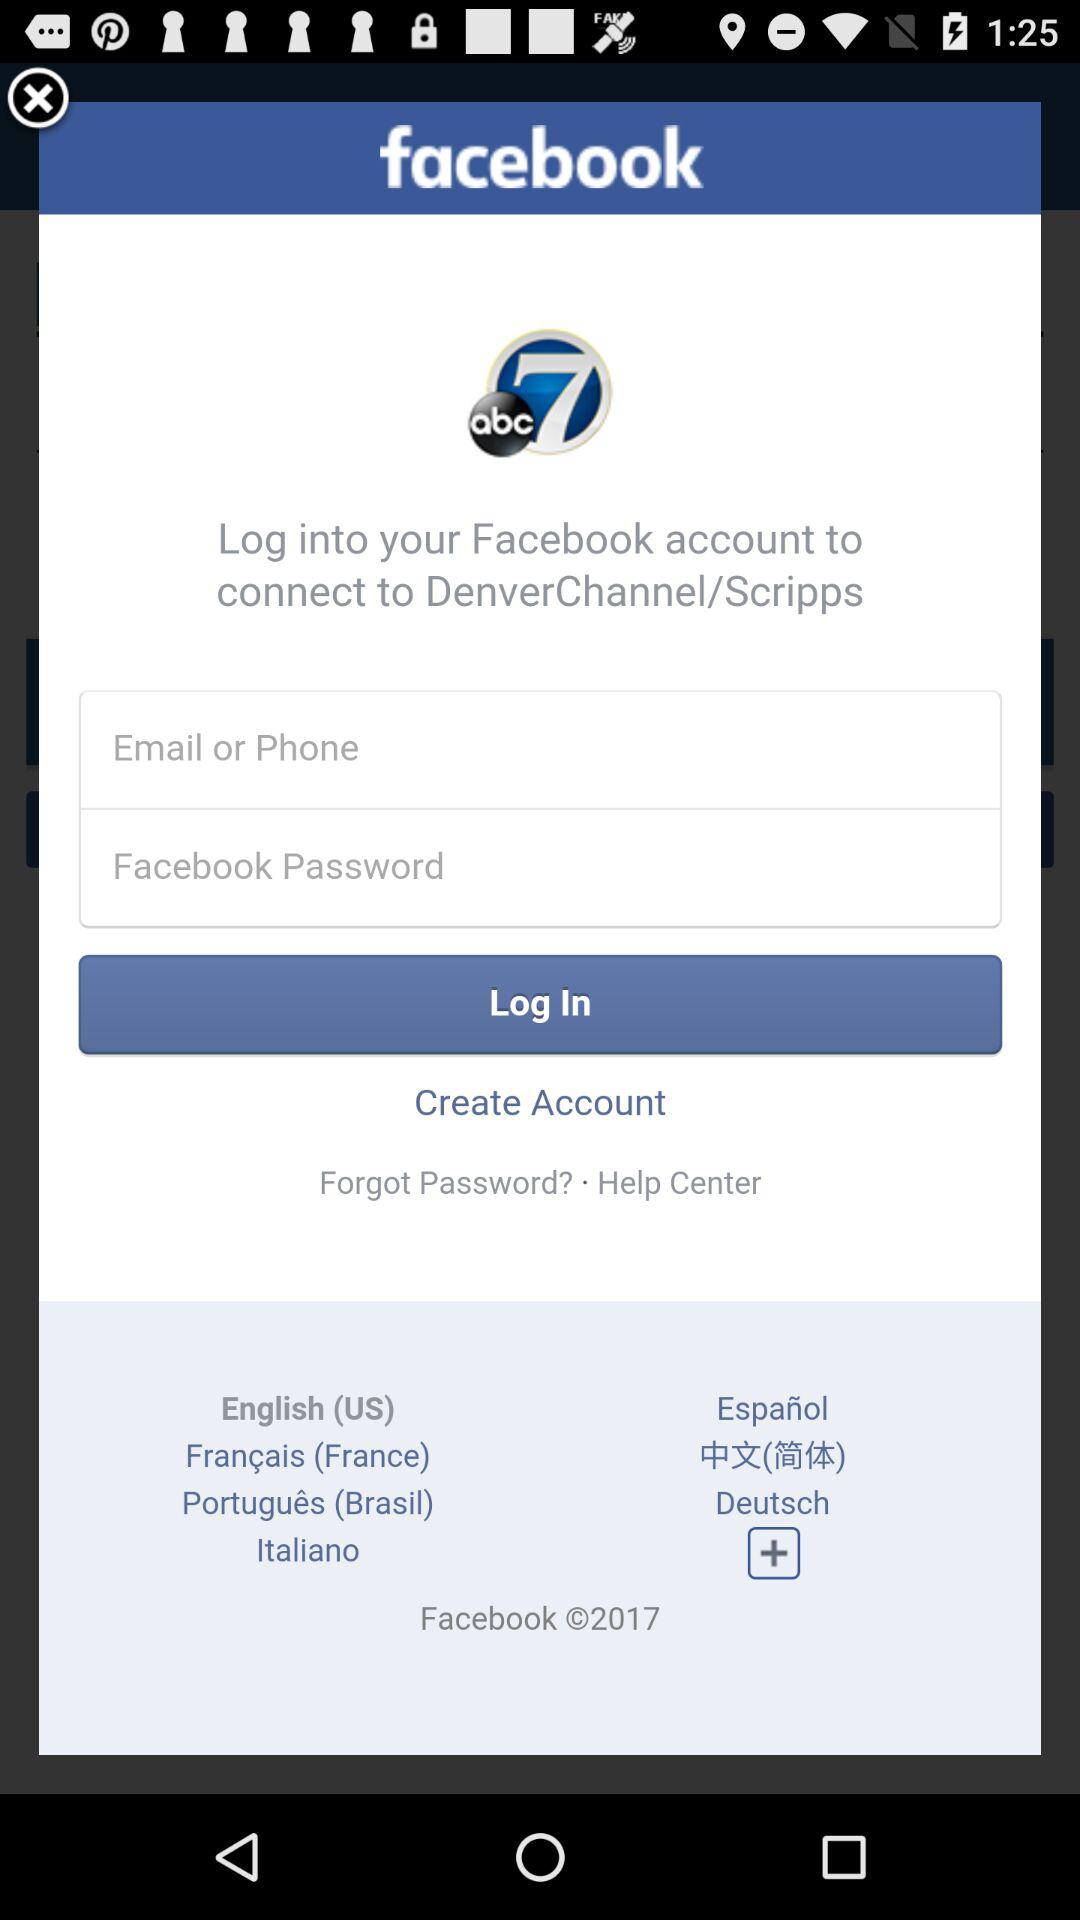What app needs the Facebook login to connect? The app that needs the Facebook login to connect is "DenverChannel/Scripps". 